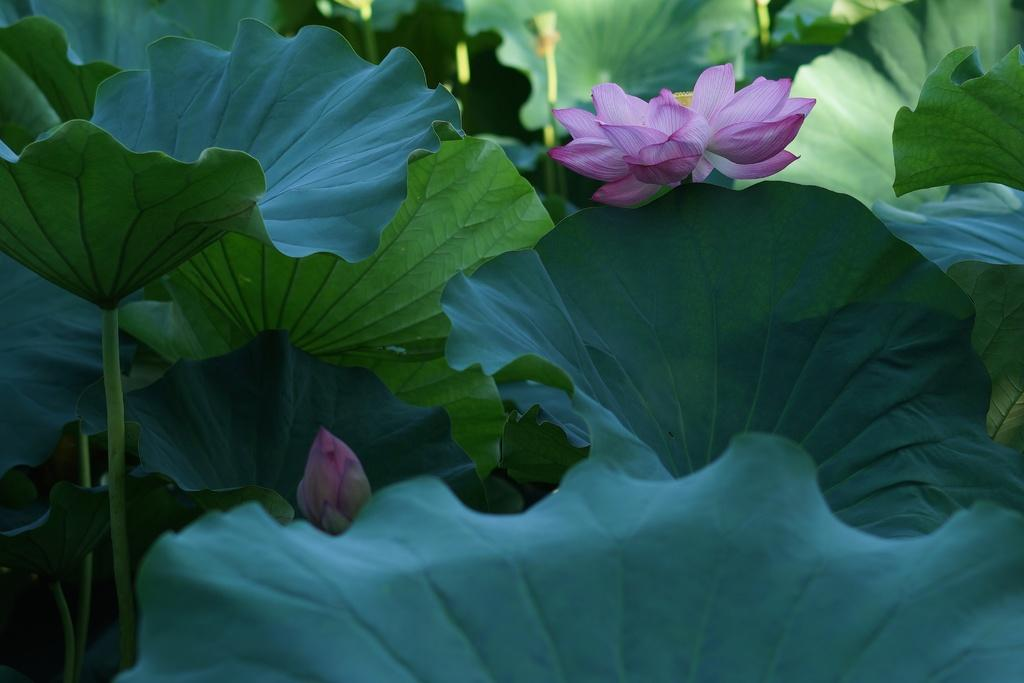What type of vegetation can be seen in the image? There are leaves of trees in the image. What color are the leaves in the image? The leaves are green in color. What other flora can be seen in the image? There are two flowers in the image. What color are the flowers in the image? The flowers are pink in color. How much wealth is represented by the flowers in the image? The image does not depict wealth or any financial value; it features flowers and leaves. 